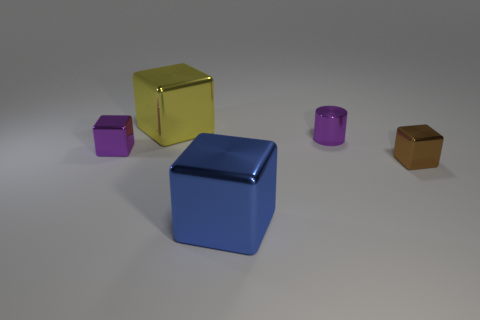Subtract all small brown cubes. How many cubes are left? 3 Subtract all yellow blocks. How many blocks are left? 3 Add 4 yellow metallic objects. How many objects exist? 9 Subtract all green blocks. Subtract all red spheres. How many blocks are left? 4 Subtract all blocks. How many objects are left? 1 Add 5 yellow metal things. How many yellow metal things exist? 6 Subtract 0 cyan balls. How many objects are left? 5 Subtract all purple metal cylinders. Subtract all purple objects. How many objects are left? 2 Add 5 tiny cubes. How many tiny cubes are left? 7 